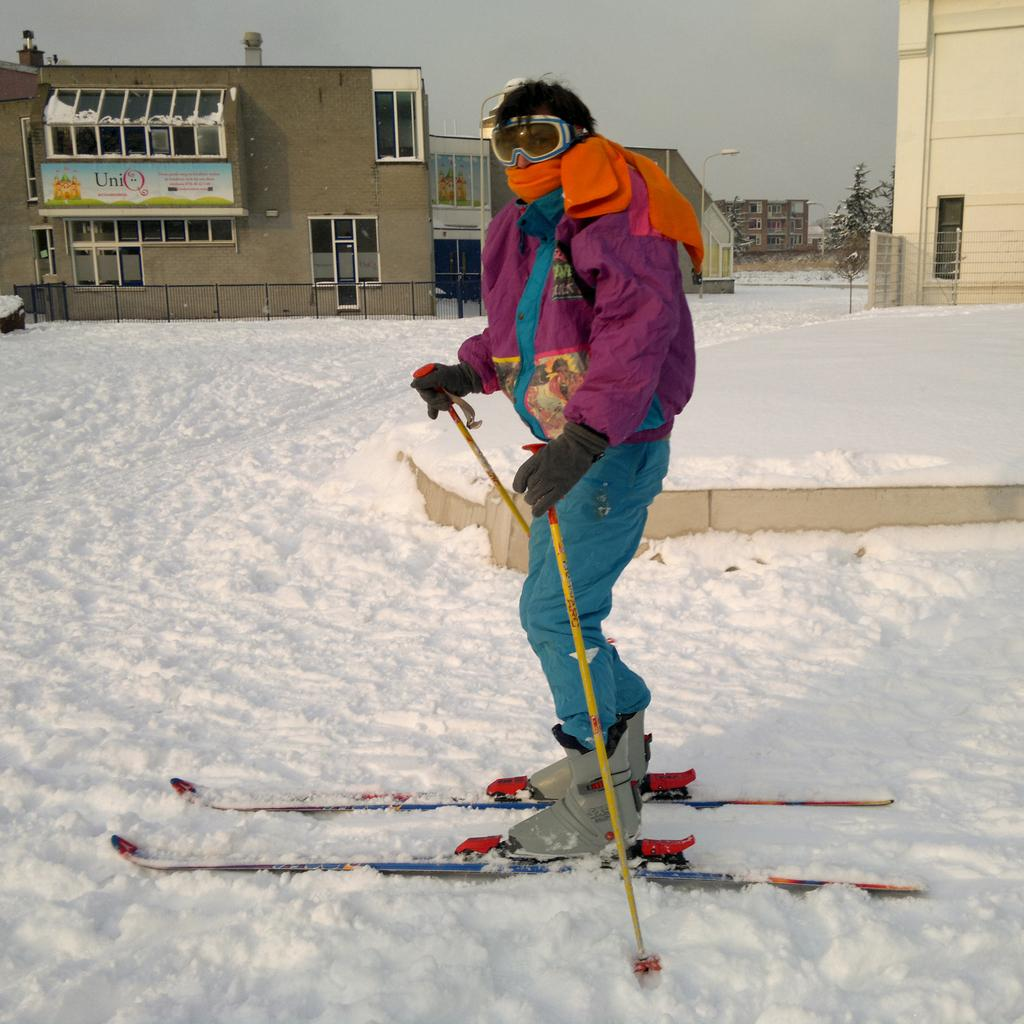Who is the main subject in the image? There is a man in the center of the image. What is the man wearing? The man is wearing a ski board. What can be seen in the background of the image? There is a building, a tree, and the sky visible in the background of the image. What is the ground covered with at the bottom of the image? There is snow at the bottom of the image. What type of care can be seen in the image? There is no care present in the image; it features a man wearing a ski board in a snowy environment. Is there a sidewalk visible in the image? No, there is no sidewalk present in the image; it shows a man wearing a ski board in a snowy environment with a building, tree, and sky in the background. 